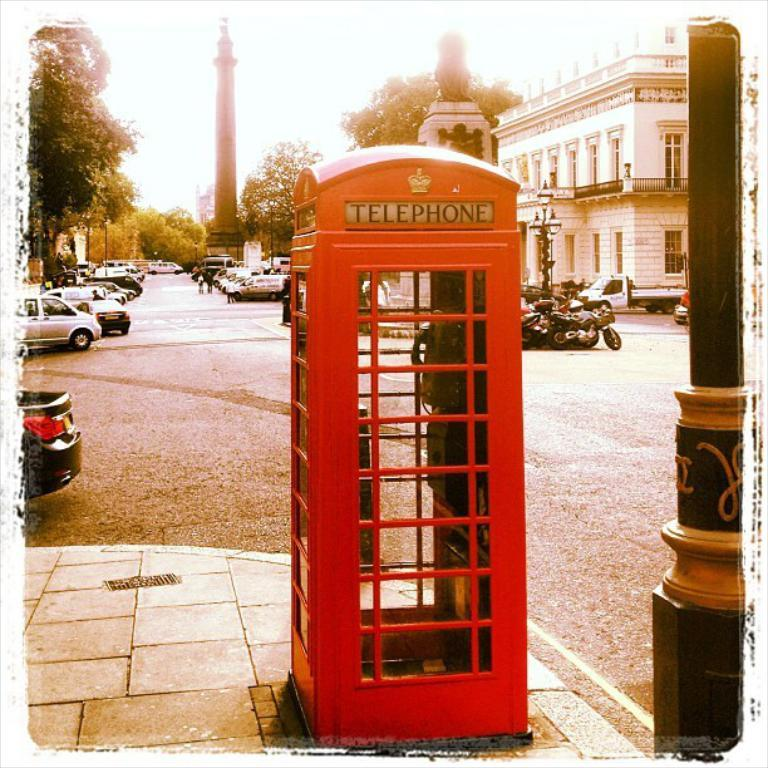<image>
Render a clear and concise summary of the photo. a telephone booth that is outside in day 